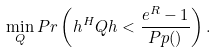<formula> <loc_0><loc_0><loc_500><loc_500>\min _ { Q } P r \left ( h ^ { H } Q h < \frac { e ^ { R } - 1 } { P p ( ) } \right ) .</formula> 